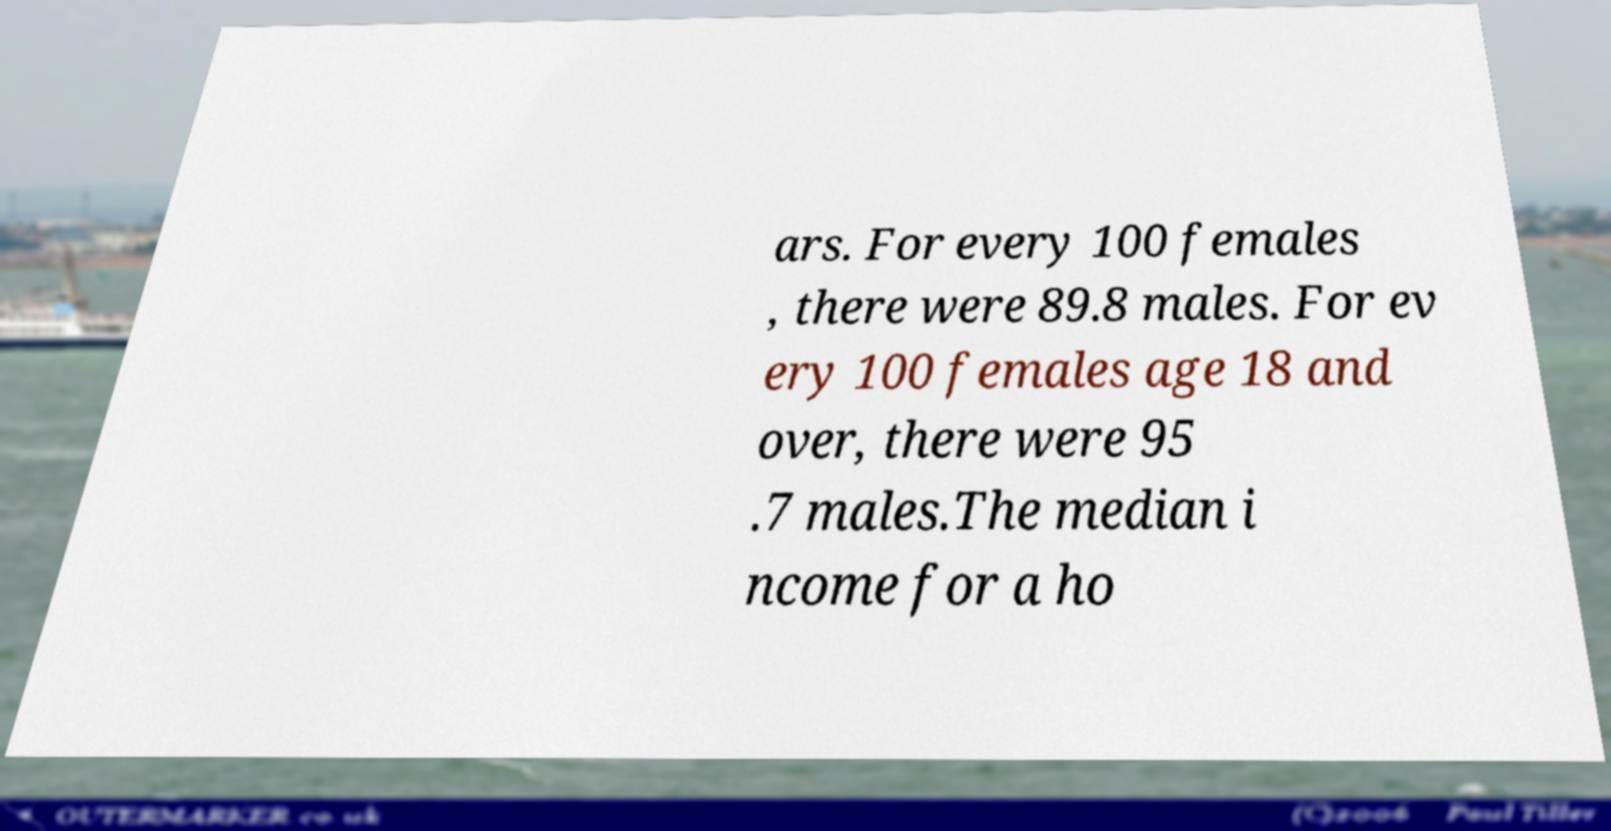Can you read and provide the text displayed in the image?This photo seems to have some interesting text. Can you extract and type it out for me? ars. For every 100 females , there were 89.8 males. For ev ery 100 females age 18 and over, there were 95 .7 males.The median i ncome for a ho 